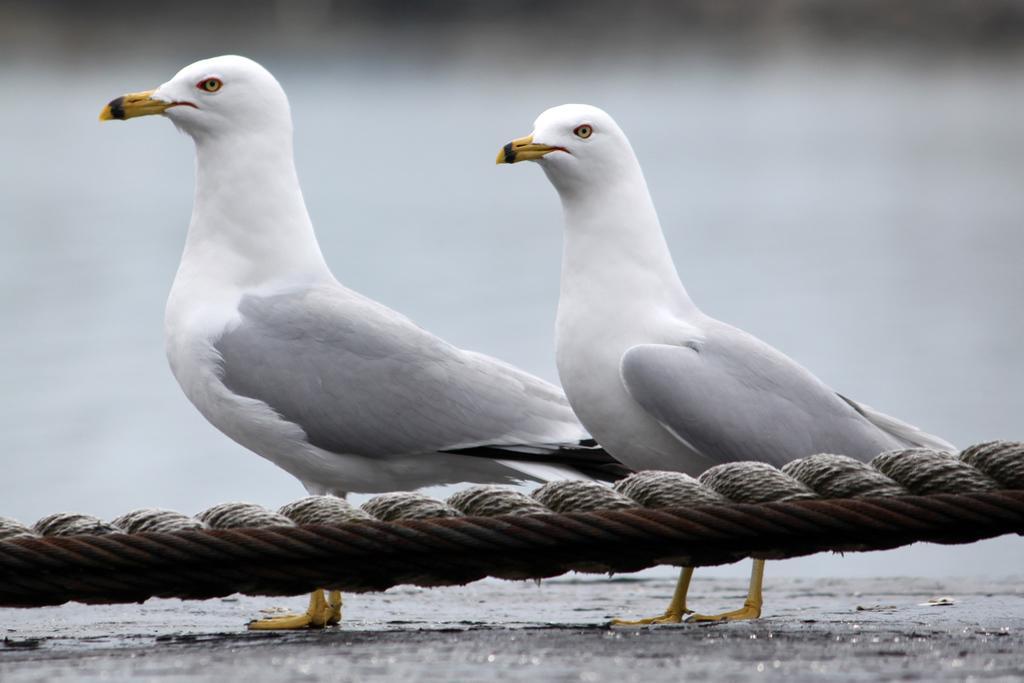Could you give a brief overview of what you see in this image? In this image we can see few birds. There are few ropes in the image. There is a blur background in the image. 